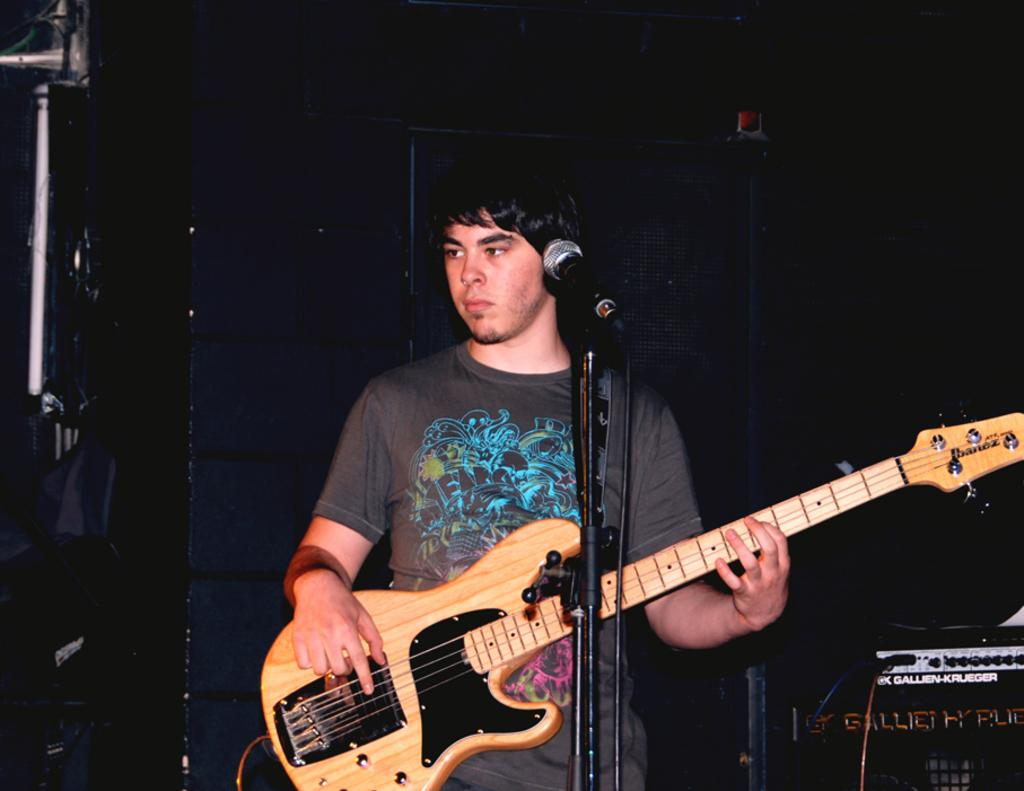Who is present in the image? There is a man in the image. What is the man holding in the image? The man is holding a guitar. What other object can be seen in the image? There is a microphone in the image. Where is the electronic device located in the image? The electronic device is in the bottom right side of the image. How many trees can be seen in the image? There are no trees present in the image. What type of snails are crawling on the microphone in the image? There are no snails present in the image, and therefore no snails can be seen on the microphone. 